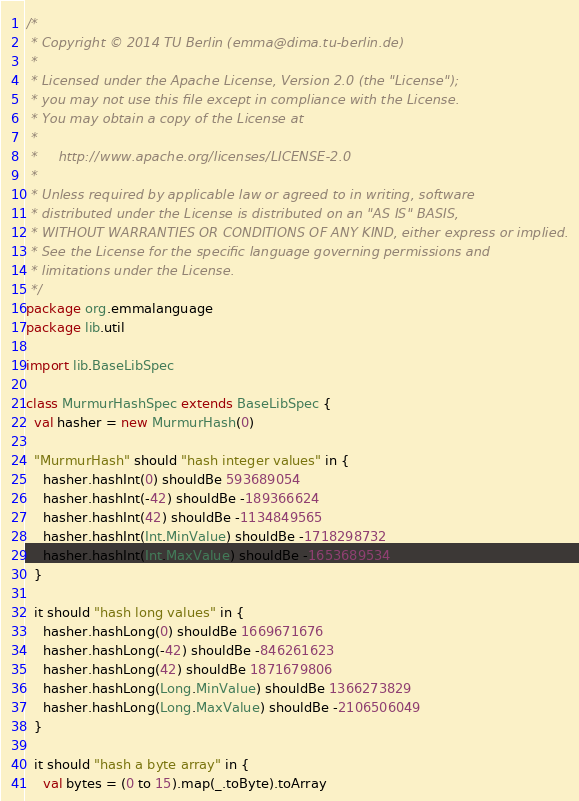Convert code to text. <code><loc_0><loc_0><loc_500><loc_500><_Scala_>/*
 * Copyright © 2014 TU Berlin (emma@dima.tu-berlin.de)
 *
 * Licensed under the Apache License, Version 2.0 (the "License");
 * you may not use this file except in compliance with the License.
 * You may obtain a copy of the License at
 *
 *     http://www.apache.org/licenses/LICENSE-2.0
 *
 * Unless required by applicable law or agreed to in writing, software
 * distributed under the License is distributed on an "AS IS" BASIS,
 * WITHOUT WARRANTIES OR CONDITIONS OF ANY KIND, either express or implied.
 * See the License for the specific language governing permissions and
 * limitations under the License.
 */
package org.emmalanguage
package lib.util

import lib.BaseLibSpec

class MurmurHashSpec extends BaseLibSpec {
  val hasher = new MurmurHash(0)

  "MurmurHash" should "hash integer values" in {
    hasher.hashInt(0) shouldBe 593689054
    hasher.hashInt(-42) shouldBe -189366624
    hasher.hashInt(42) shouldBe -1134849565
    hasher.hashInt(Int.MinValue) shouldBe -1718298732
    hasher.hashInt(Int.MaxValue) shouldBe -1653689534
  }

  it should "hash long values" in {
    hasher.hashLong(0) shouldBe 1669671676
    hasher.hashLong(-42) shouldBe -846261623
    hasher.hashLong(42) shouldBe 1871679806
    hasher.hashLong(Long.MinValue) shouldBe 1366273829
    hasher.hashLong(Long.MaxValue) shouldBe -2106506049
  }

  it should "hash a byte array" in {
    val bytes = (0 to 15).map(_.toByte).toArray</code> 